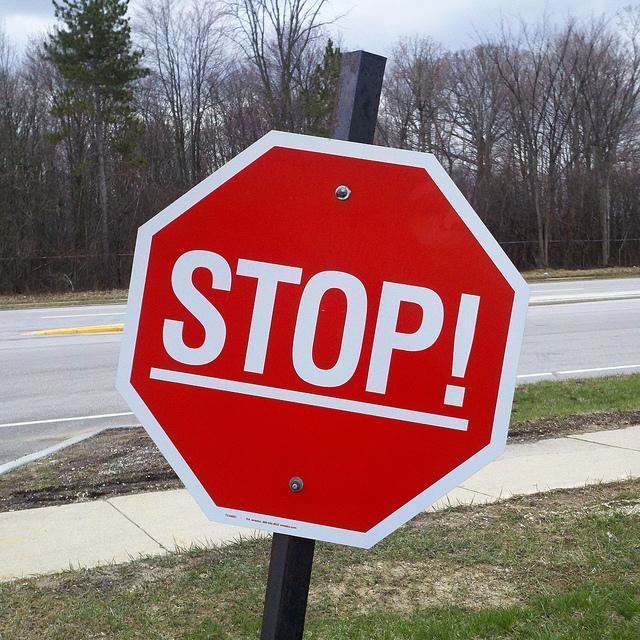How many screws are attached to the sign?
Give a very brief answer. 2. 